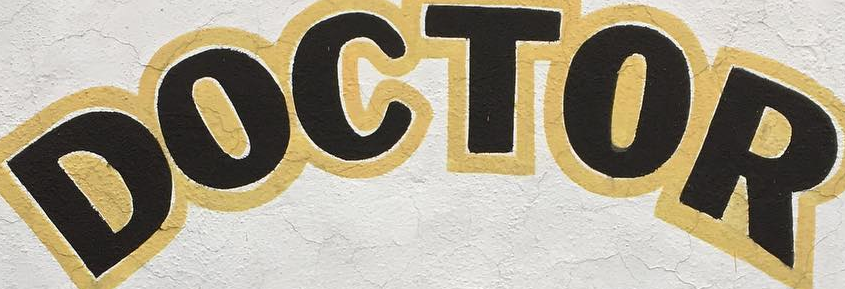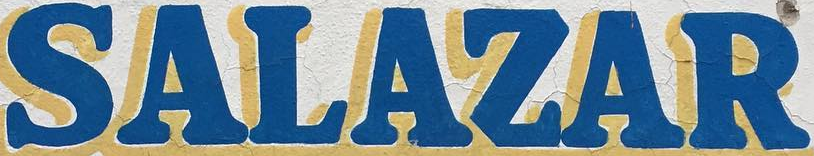What words are shown in these images in order, separated by a semicolon? DOCTOR; SALAZAR 